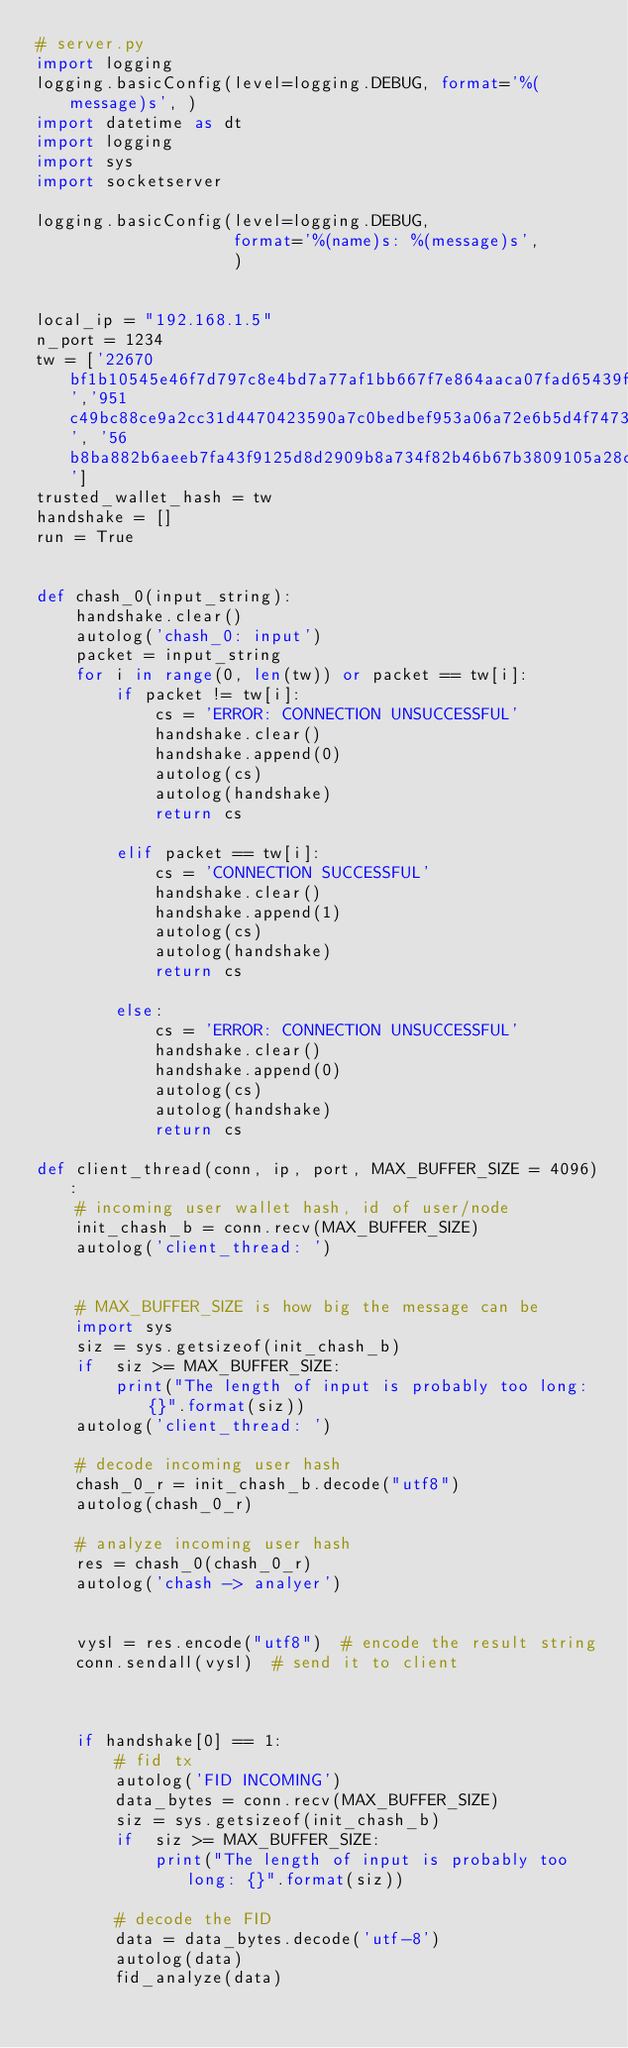Convert code to text. <code><loc_0><loc_0><loc_500><loc_500><_Python_># server.py
import logging
logging.basicConfig(level=logging.DEBUG, format='%(message)s', )
import datetime as dt
import logging
import sys
import socketserver

logging.basicConfig(level=logging.DEBUG,
                    format='%(name)s: %(message)s',
                    )


local_ip = "192.168.1.5"
n_port = 1234
tw = ['22670bf1b10545e46f7d797c8e4bd7a77af1bb667f7e864aaca07fad65439f84','951c49bc88ce9a2cc31d4470423590a7c0bedbef953a06a72e6b5d4f74731ed6', '56b8ba882b6aeeb7fa43f9125d8d2909b8a734f82b46b67b3809105a28cfb05d']
trusted_wallet_hash = tw
handshake = []
run = True


def chash_0(input_string):  
    handshake.clear()
    autolog('chash_0: input')
    packet = input_string
    for i in range(0, len(tw)) or packet == tw[i]:
        if packet != tw[i]:
            cs = 'ERROR: CONNECTION UNSUCCESSFUL'
            handshake.clear()
            handshake.append(0)
            autolog(cs)
            autolog(handshake)
            return cs

        elif packet == tw[i]:
            cs = 'CONNECTION SUCCESSFUL'
            handshake.clear()
            handshake.append(1)
            autolog(cs)
            autolog(handshake)
            return cs
        
        else:
            cs = 'ERROR: CONNECTION UNSUCCESSFUL'
            handshake.clear()
            handshake.append(0)
            autolog(cs)
            autolog(handshake)
            return cs

def client_thread(conn, ip, port, MAX_BUFFER_SIZE = 4096):
    # incoming user wallet hash, id of user/node
    init_chash_b = conn.recv(MAX_BUFFER_SIZE)
    autolog('client_thread: ')
    
    
    # MAX_BUFFER_SIZE is how big the message can be
    import sys
    siz = sys.getsizeof(init_chash_b)
    if  siz >= MAX_BUFFER_SIZE:
        print("The length of input is probably too long: {}".format(siz))
    autolog('client_thread: ')
    
    # decode incoming user hash 
    chash_0_r = init_chash_b.decode("utf8")
    autolog(chash_0_r)

    # analyze incoming user hash
    res = chash_0(chash_0_r)
    autolog('chash -> analyer')
    
    
    vysl = res.encode("utf8")  # encode the result string
    conn.sendall(vysl)  # send it to client
    
    
    
    if handshake[0] == 1:
        # fid tx
        autolog('FID INCOMING')
        data_bytes = conn.recv(MAX_BUFFER_SIZE)
        siz = sys.getsizeof(init_chash_b)
        if  siz >= MAX_BUFFER_SIZE:
            print("The length of input is probably too long: {}".format(siz))
        
        # decode the FID 
        data = data_bytes.decode('utf-8')
        autolog(data)
        fid_analyze(data)
</code> 